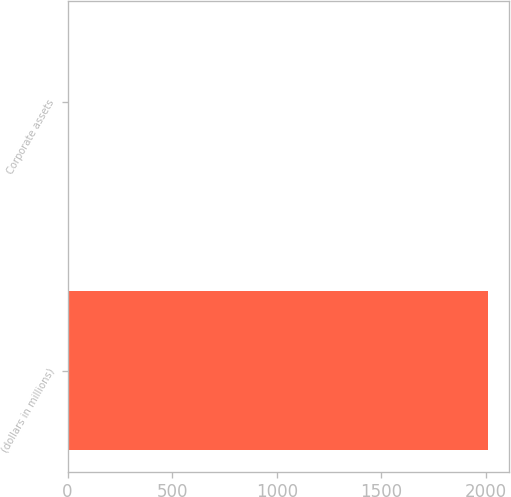Convert chart. <chart><loc_0><loc_0><loc_500><loc_500><bar_chart><fcel>(dollars in millions)<fcel>Corporate assets<nl><fcel>2009<fcel>0.5<nl></chart> 